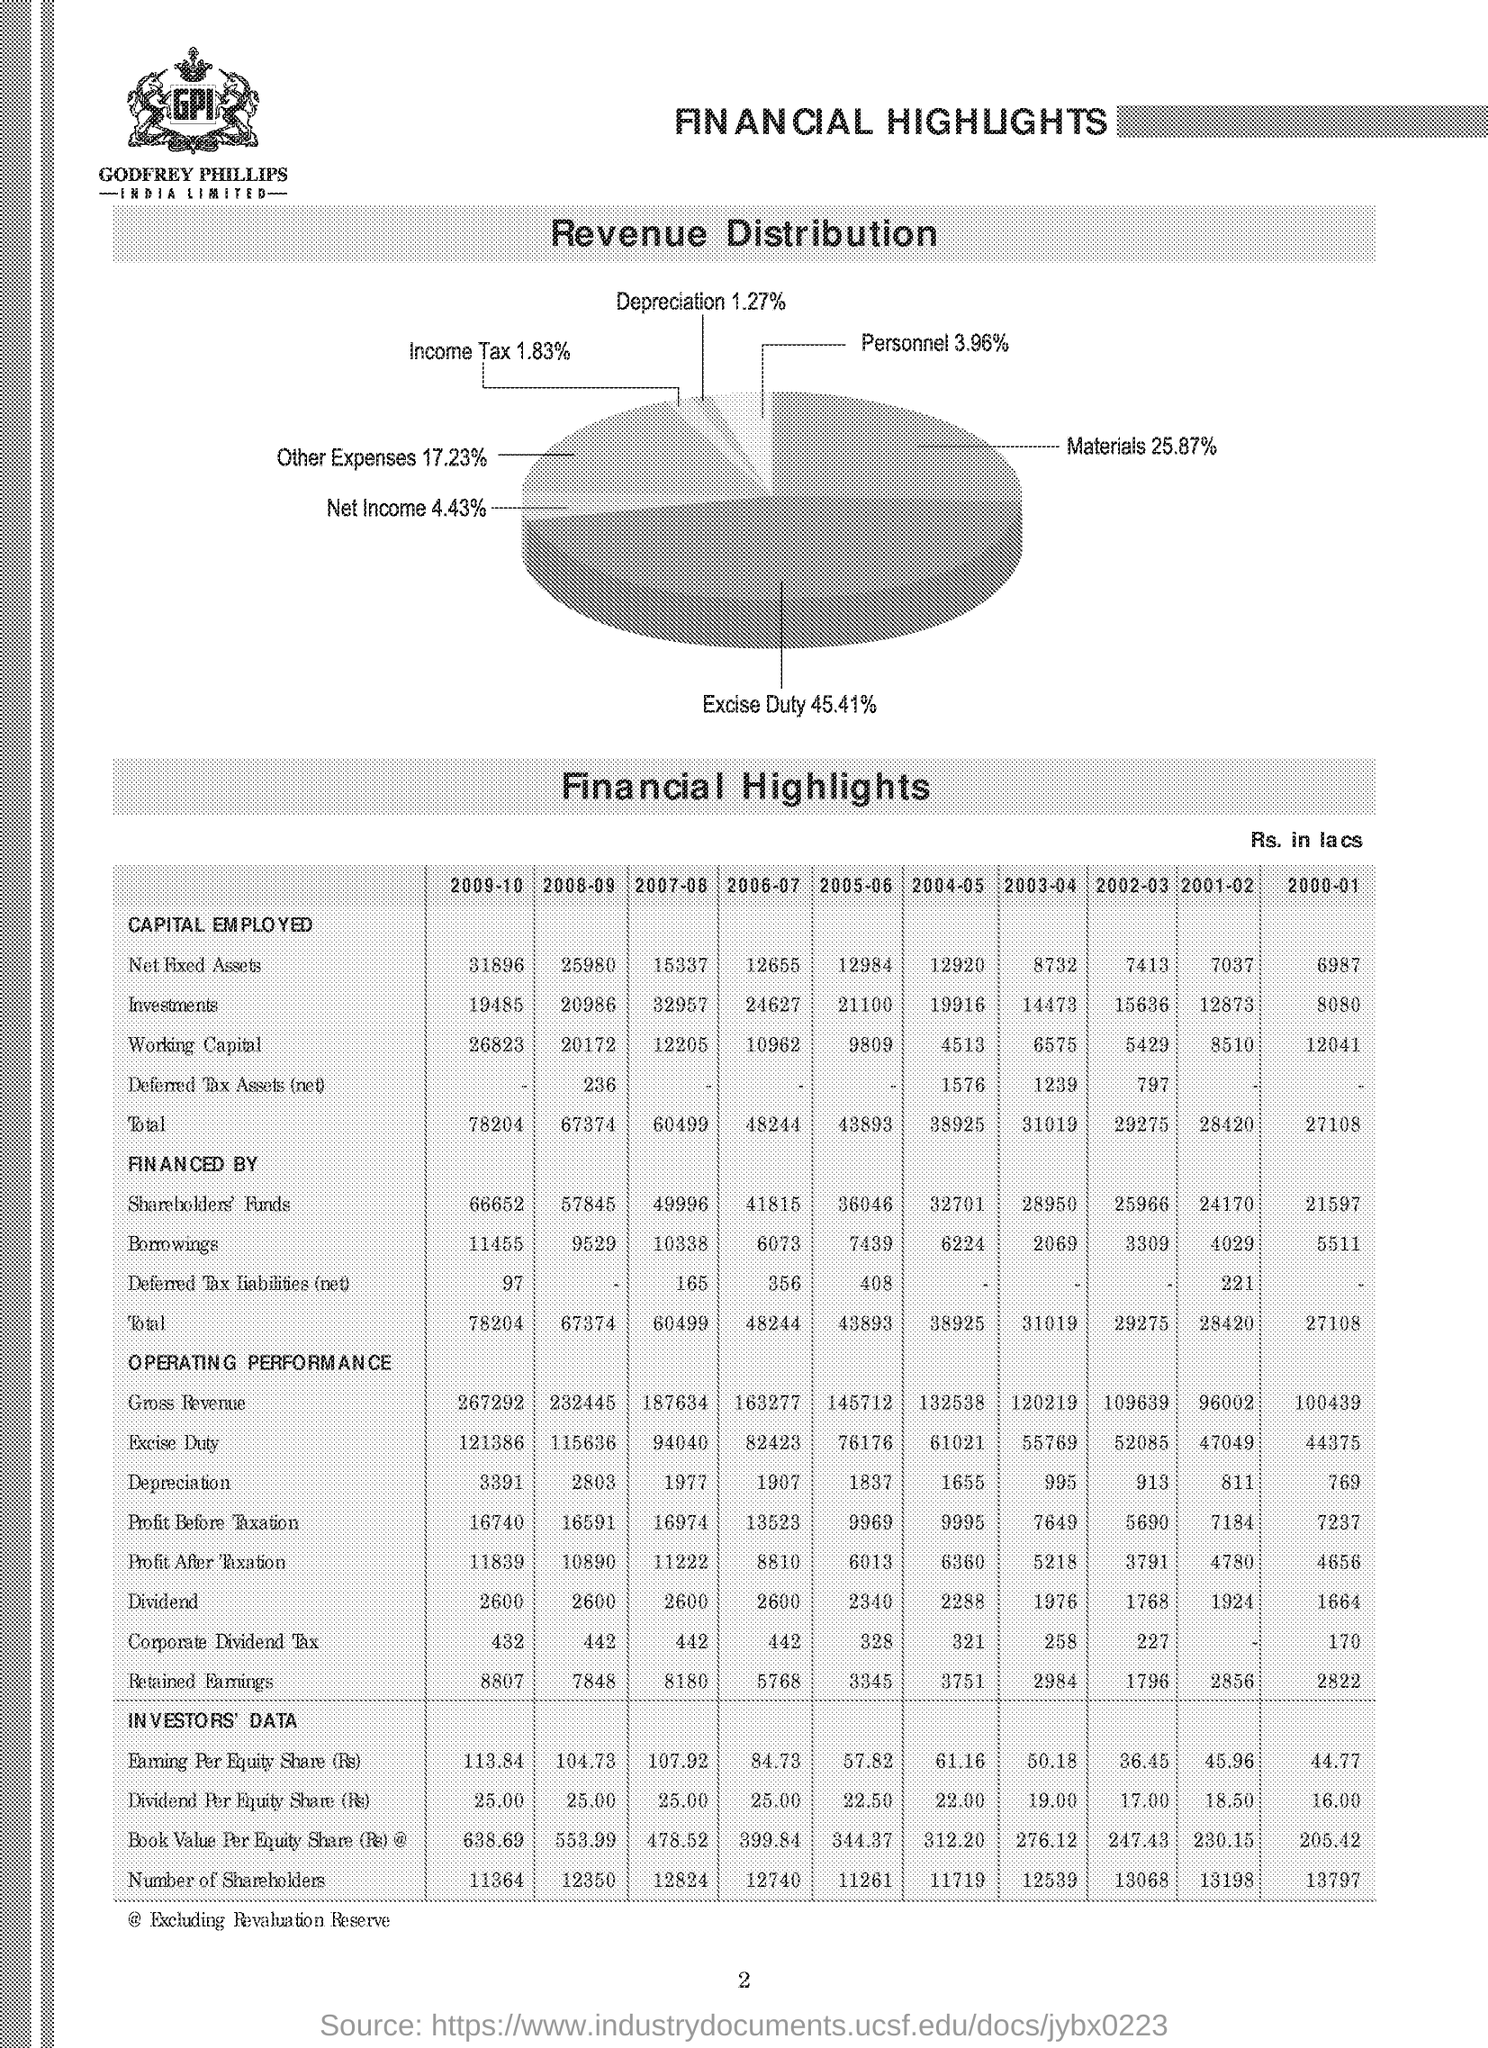What is the depreciation % in the revenue distribution ?
Ensure brevity in your answer.  1.27. What is the materials % in revenue distribution?
Make the answer very short. 25.87%. What is the total capital employed for the year 2009-10?
Provide a short and direct response. 78204. What is the income tax % in the revenue distribution ?
Provide a succinct answer. 1.83%. What is the excise duty % in the revenue distribution ?
Your answer should be compact. 45.41%. 